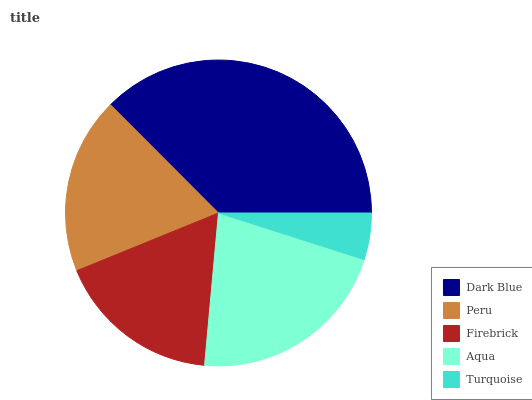Is Turquoise the minimum?
Answer yes or no. Yes. Is Dark Blue the maximum?
Answer yes or no. Yes. Is Peru the minimum?
Answer yes or no. No. Is Peru the maximum?
Answer yes or no. No. Is Dark Blue greater than Peru?
Answer yes or no. Yes. Is Peru less than Dark Blue?
Answer yes or no. Yes. Is Peru greater than Dark Blue?
Answer yes or no. No. Is Dark Blue less than Peru?
Answer yes or no. No. Is Peru the high median?
Answer yes or no. Yes. Is Peru the low median?
Answer yes or no. Yes. Is Dark Blue the high median?
Answer yes or no. No. Is Firebrick the low median?
Answer yes or no. No. 